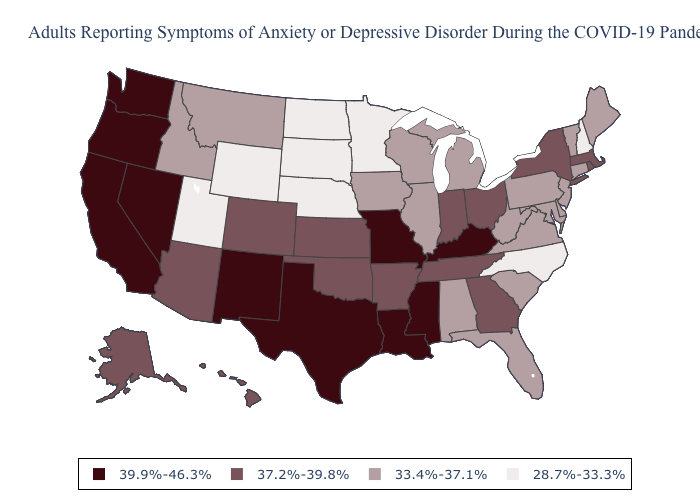What is the value of Alaska?
Quick response, please. 37.2%-39.8%. Which states have the highest value in the USA?
Be succinct. California, Kentucky, Louisiana, Mississippi, Missouri, Nevada, New Mexico, Oregon, Texas, Washington. Among the states that border Vermont , which have the highest value?
Keep it brief. Massachusetts, New York. What is the highest value in the USA?
Keep it brief. 39.9%-46.3%. Name the states that have a value in the range 37.2%-39.8%?
Concise answer only. Alaska, Arizona, Arkansas, Colorado, Georgia, Hawaii, Indiana, Kansas, Massachusetts, New York, Ohio, Oklahoma, Rhode Island, Tennessee. Does Maine have the highest value in the Northeast?
Answer briefly. No. Does the map have missing data?
Concise answer only. No. Does Georgia have a lower value than Missouri?
Be succinct. Yes. What is the value of New Hampshire?
Quick response, please. 28.7%-33.3%. What is the highest value in the Northeast ?
Short answer required. 37.2%-39.8%. Among the states that border Arkansas , which have the highest value?
Keep it brief. Louisiana, Mississippi, Missouri, Texas. Among the states that border Arkansas , which have the highest value?
Concise answer only. Louisiana, Mississippi, Missouri, Texas. What is the lowest value in the West?
Concise answer only. 28.7%-33.3%. Name the states that have a value in the range 39.9%-46.3%?
Keep it brief. California, Kentucky, Louisiana, Mississippi, Missouri, Nevada, New Mexico, Oregon, Texas, Washington. Among the states that border West Virginia , which have the highest value?
Answer briefly. Kentucky. 